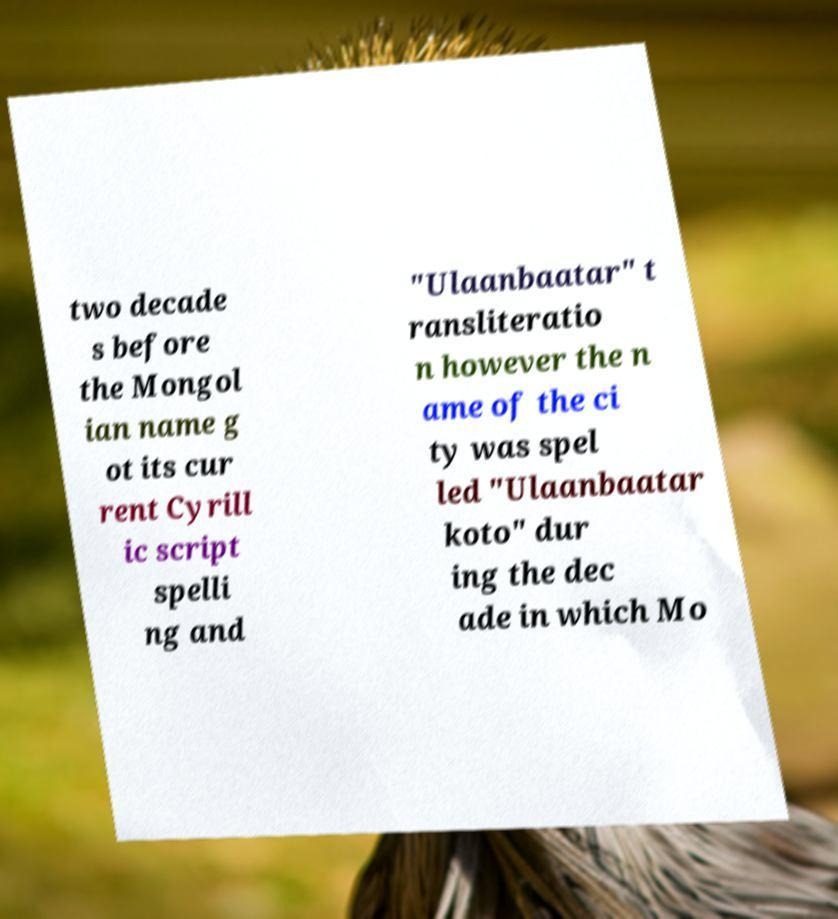I need the written content from this picture converted into text. Can you do that? two decade s before the Mongol ian name g ot its cur rent Cyrill ic script spelli ng and "Ulaanbaatar" t ransliteratio n however the n ame of the ci ty was spel led "Ulaanbaatar koto" dur ing the dec ade in which Mo 